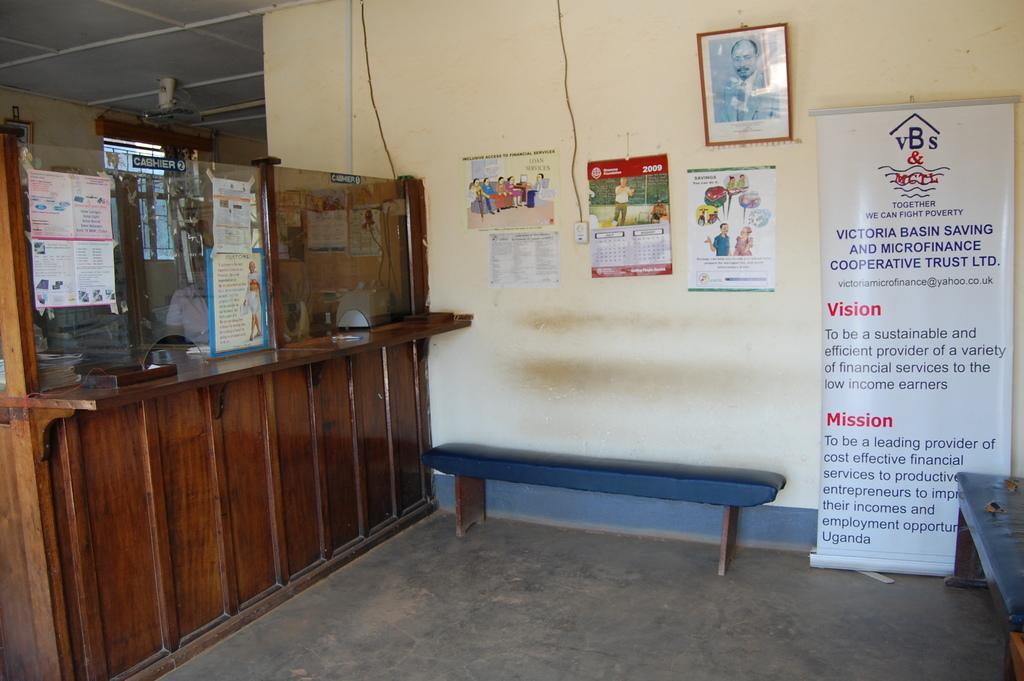How would you summarize this image in a sentence or two? In this picture there is a bench poster and some charts were hanged to the wall along with some photo frame. In the left side there is wooden wall here. 